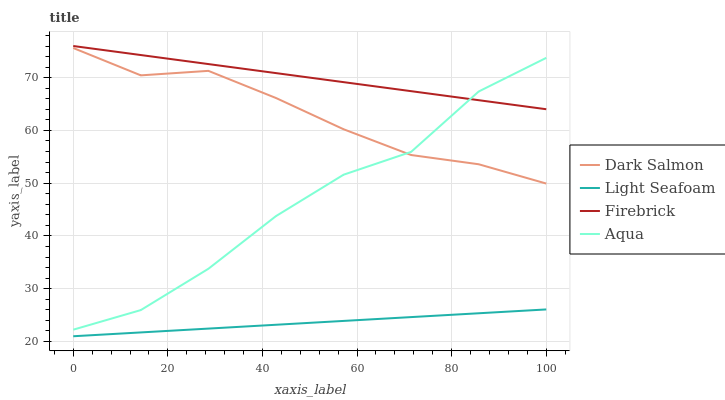Does Light Seafoam have the minimum area under the curve?
Answer yes or no. Yes. Does Firebrick have the maximum area under the curve?
Answer yes or no. Yes. Does Aqua have the minimum area under the curve?
Answer yes or no. No. Does Aqua have the maximum area under the curve?
Answer yes or no. No. Is Light Seafoam the smoothest?
Answer yes or no. Yes. Is Aqua the roughest?
Answer yes or no. Yes. Is Aqua the smoothest?
Answer yes or no. No. Is Light Seafoam the roughest?
Answer yes or no. No. Does Light Seafoam have the lowest value?
Answer yes or no. Yes. Does Aqua have the lowest value?
Answer yes or no. No. Does Firebrick have the highest value?
Answer yes or no. Yes. Does Aqua have the highest value?
Answer yes or no. No. Is Light Seafoam less than Aqua?
Answer yes or no. Yes. Is Aqua greater than Light Seafoam?
Answer yes or no. Yes. Does Firebrick intersect Aqua?
Answer yes or no. Yes. Is Firebrick less than Aqua?
Answer yes or no. No. Is Firebrick greater than Aqua?
Answer yes or no. No. Does Light Seafoam intersect Aqua?
Answer yes or no. No. 